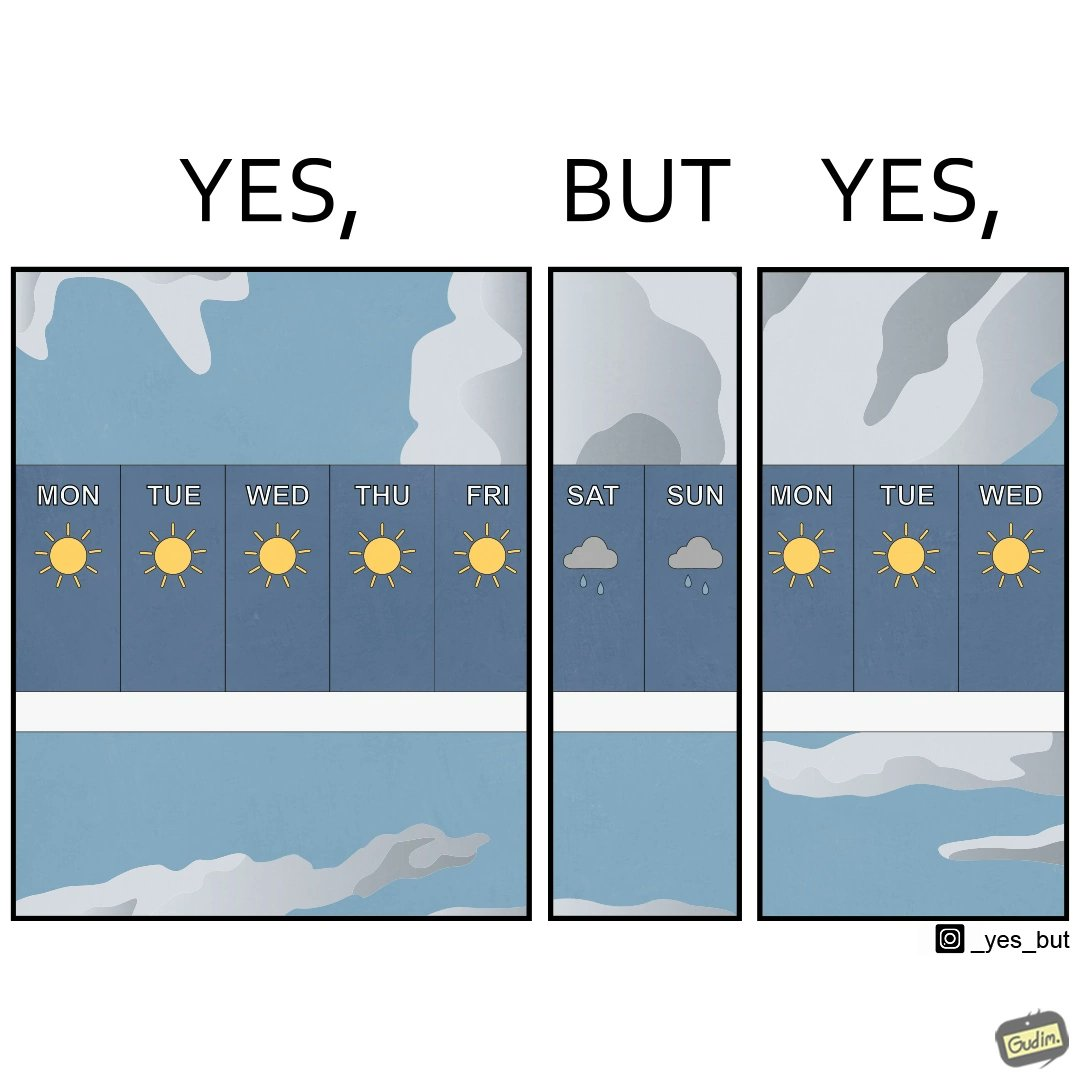Describe the content of this image. The image is funny, as the weather is sunny during the weekdays, which are generally the days when people work in a job. People look forward to go outside and enjoy in the weekend, but due to an unexpected rainy weather, people will not be able to go outside. 